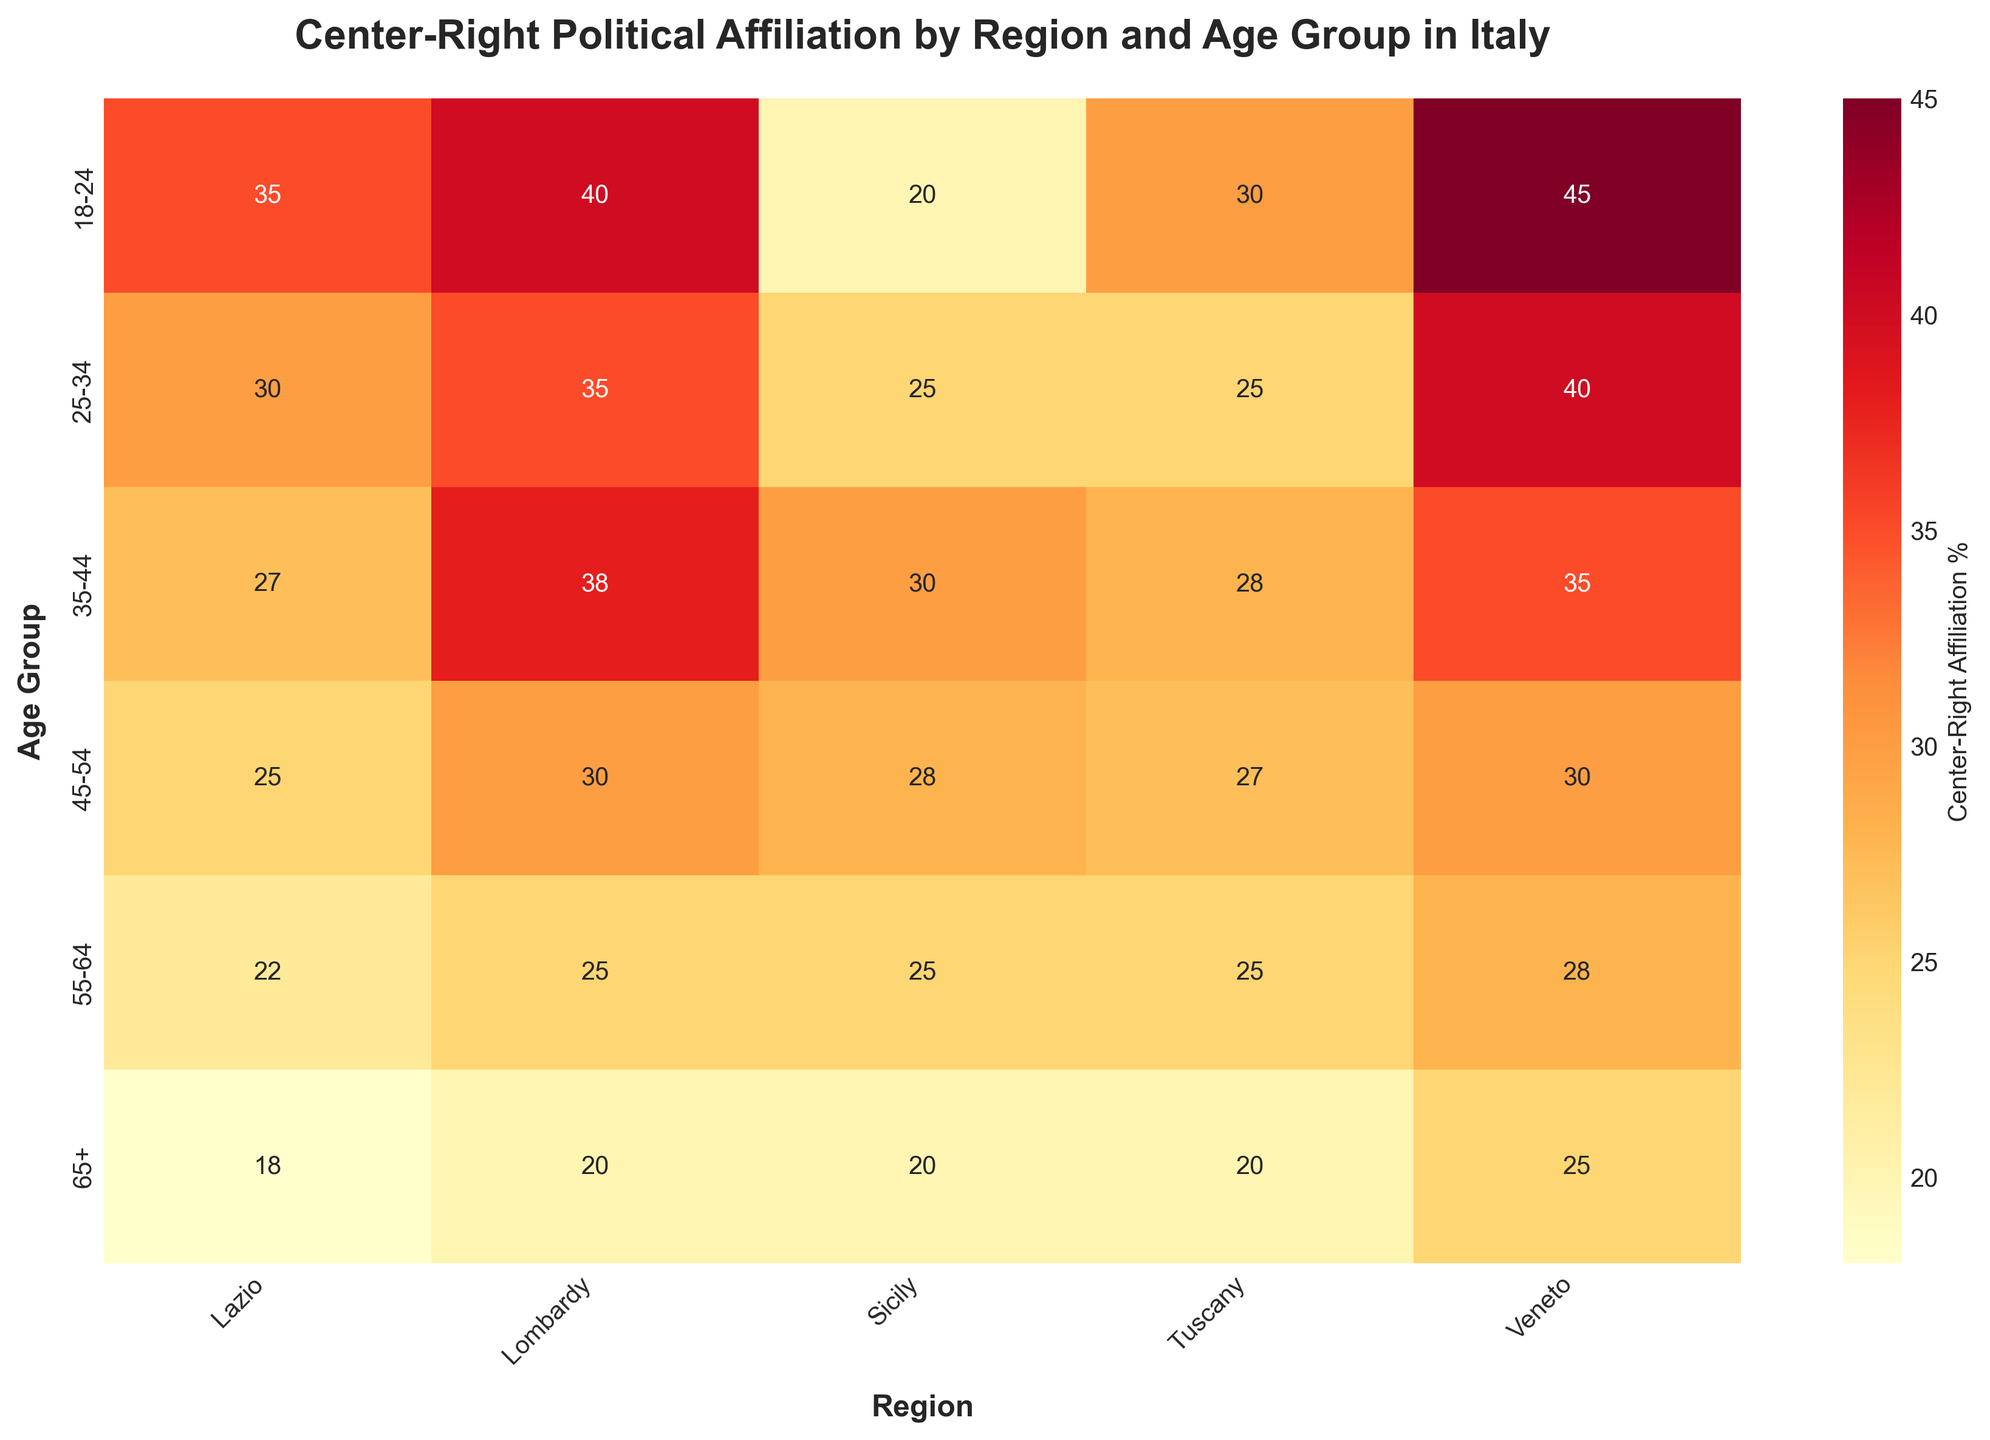What is the title of the heatmap? The title is located at the top of the heatmap and it describes the content and purpose of the figure. It reads "Center-Right Political Affiliation by Region and Age Group in Italy."
Answer: Center-Right Political Affiliation by Region and Age Group in Italy Which region and age group has the highest center-right political affiliation? By observing the values in the heatmap, the highest percentage value among all the regions and age groups in the center-right affiliation is 45%, found in the Veneto region for the 18-24 age group.
Answer: Veneto, 18-24 What is the center-right political affiliation percentage for the 55-64 age group in Lazio? By locating the 55-64 age group row and finding the column for Lazio, the percentage value is 22%.
Answer: 22% Which region shows the lowest center-right political affiliation percentage for the 65+ age group? By looking at the values in the 65+ age group row across all regions, the lowest value is in Tuscany, which is 20%.
Answer: Tuscany Among the regions, which has a consistently high center-right affiliation across all age groups? Examining the consistency of high percentages across all age groups, Veneto has relatively high values ranging from 25% to 45%.
Answer: Veneto How does the center-right affiliation for the 25-34 age group in Sicily compare to that in Lombardy? Comparing the values from the heatmap for the 25-34 age group in Sicily (25%) and Lombardy (35%), Lombardy has a higher percentage.
Answer: Lombardy has a higher percentage What is the average center-right political affiliation percentage for all age groups in Tuscany? Summing the percentages for each age group in Tuscany: 30 + 25 + 28 + 27 + 25 + 20 = 155, then dividing by the number of age groups (6), we get 155 / 6 ≈ 25.83%.
Answer: 25.83% Which region has the largest decrease in center-right political affiliation between the 18-24 and 65+ age groups? Comparing the values from 18-24 to 65+ in each region: Lombardy (40 to 20, decrease of 20), Lazio (35 to 18, decrease of 17), Sicily (20 to 20, no change), Tuscany (30 to 20, decrease of 10), and Veneto (45 to 25, decrease of 20). Lombardy and Veneto both have the largest decrease of 20%.
Answer: Lombardy and Veneto Is there a consistent trend in center-right political affiliation as age increases in any region? Observing the trend across age groups for each region shows that in most regions, there is a general decrease in younger age groups, but increases or stable trends in older age groups. For example, Veneto shows a decreasing trend as age increases from 45% in 18-24 to 25% in 65+.
Answer: Observed in Veneto What percentage of center-right affiliation is shown for the 35-44 age group in Lombardy? By locating Lombardy's column in the 35-44 age group row, the percentage is 38%.
Answer: 38% 